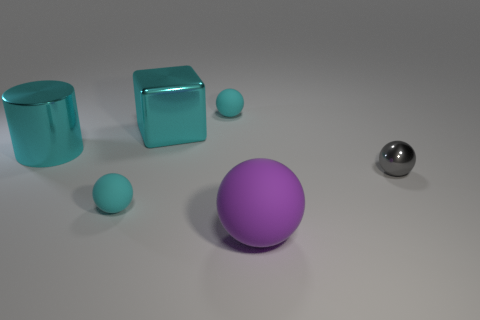Is the shiny cylinder the same size as the cyan metal cube?
Provide a short and direct response. Yes. Is the number of metal cylinders greater than the number of blue metal things?
Your answer should be compact. Yes. What number of other things are there of the same color as the large shiny block?
Ensure brevity in your answer.  3. What number of things are large blue objects or cyan spheres?
Your answer should be compact. 2. There is a small thing right of the purple object; does it have the same shape as the purple rubber object?
Provide a short and direct response. Yes. There is a tiny object left of the tiny cyan ball that is behind the cyan cylinder; what color is it?
Ensure brevity in your answer.  Cyan. Are there fewer cyan cubes than large gray metallic cubes?
Your response must be concise. No. Is there another small cylinder that has the same material as the cylinder?
Give a very brief answer. No. Do the large purple rubber object and the tiny cyan matte object that is to the left of the large shiny cube have the same shape?
Ensure brevity in your answer.  Yes. Are there any big cyan cylinders on the right side of the gray metallic object?
Keep it short and to the point. No. 